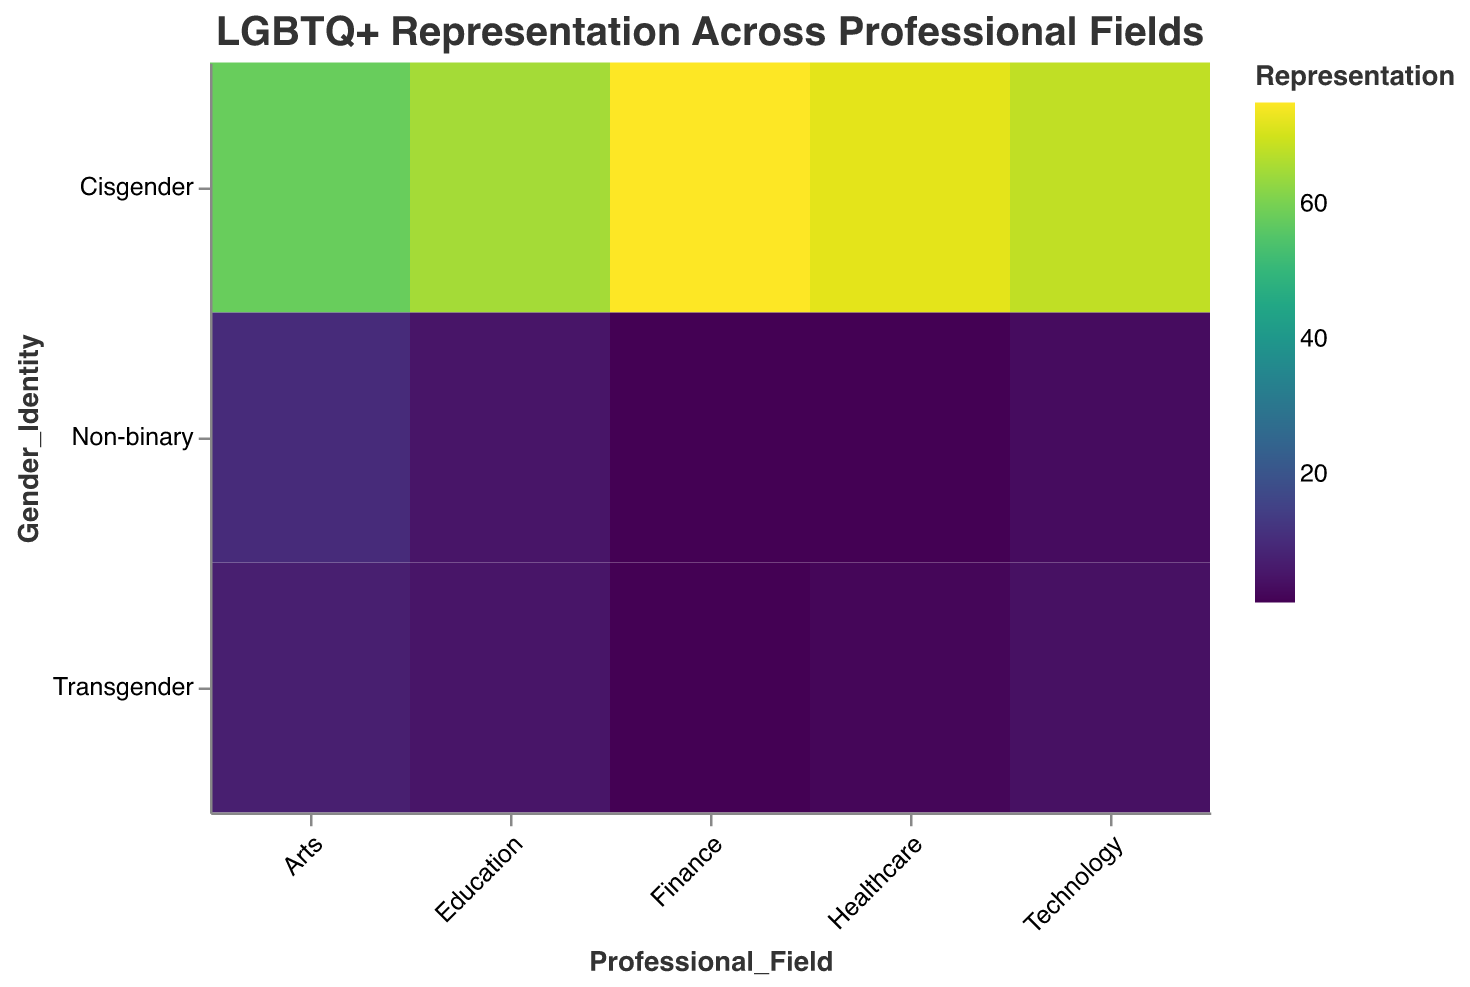What is the title of the figure? The title is located at the top of the figure and provides a brief summary of the visualized data. It is labeled as "LGBTQ+ Representation Across Professional Fields".
Answer: LGBTQ+ Representation Across Professional Fields How many professional fields are represented in the figure? Counting the unique categories on the x-axis, there are 5 professional fields represented: Technology, Healthcare, Education, Finance, and Arts.
Answer: 5 Which professional field has the highest representation of Transgender individuals? By comparing the sizes and colors of the rectangles for Transgender in each professional field, the Arts field stands out with the highest representation.
Answer: Arts What is the representation of Non-binary individuals in the Healthcare field? Locate the intersection of Healthcare and Non-binary on the plot and refer to the color and size of the rectangle, the value is 1.
Answer: 1 How does the representation of Cisgender individuals in Finance compare to Education? Find the rectangles for Cisgender in both Finance and Education, then compare their sizes and colors. Finance has a higher representation with a value of 75 compared to Education's 65.
Answer: Finance has higher representation What is the total representation of LGBTQ+ individuals (Transgender + Non-binary) in the Technology field? Add the representation values for Transgender (4) and Non-binary (3) individuals in Technology. 4 + 3 = 7
Answer: 7 Which professional field has the overall lowest representation of Non-binary individuals? By comparing the Non-binary values across all fields, Healthcare and Finance both have the lowest representation with a value of 1.
Answer: Healthcare and Finance What is the difference in representation between Cisgender and Non-binary individuals in Arts? Subtract the Non-binary representation (10) from the Cisgender representation (58) in the Arts field. 58 - 10 = 48
Answer: 48 How does the total representation of LGBTQ+ individuals in the Education field compare to the Arts field? Add Transgender and Non-binary representations for both fields and compare the totals. Education: 5 + 5 = 10, Arts: 7 + 10 = 17. Arts has higher total representation.
Answer: Arts has higher total representation Which professional field has the most balanced representation across Cisgender, Transgender, and Non-binary identities? By visually inspecting which field has the most evenly sized and colored rectangles among the three identities, Education appears most balanced with closest values of 65 (Cisgender), 5 (Transgender), and 5 (Non-binary).
Answer: Education 